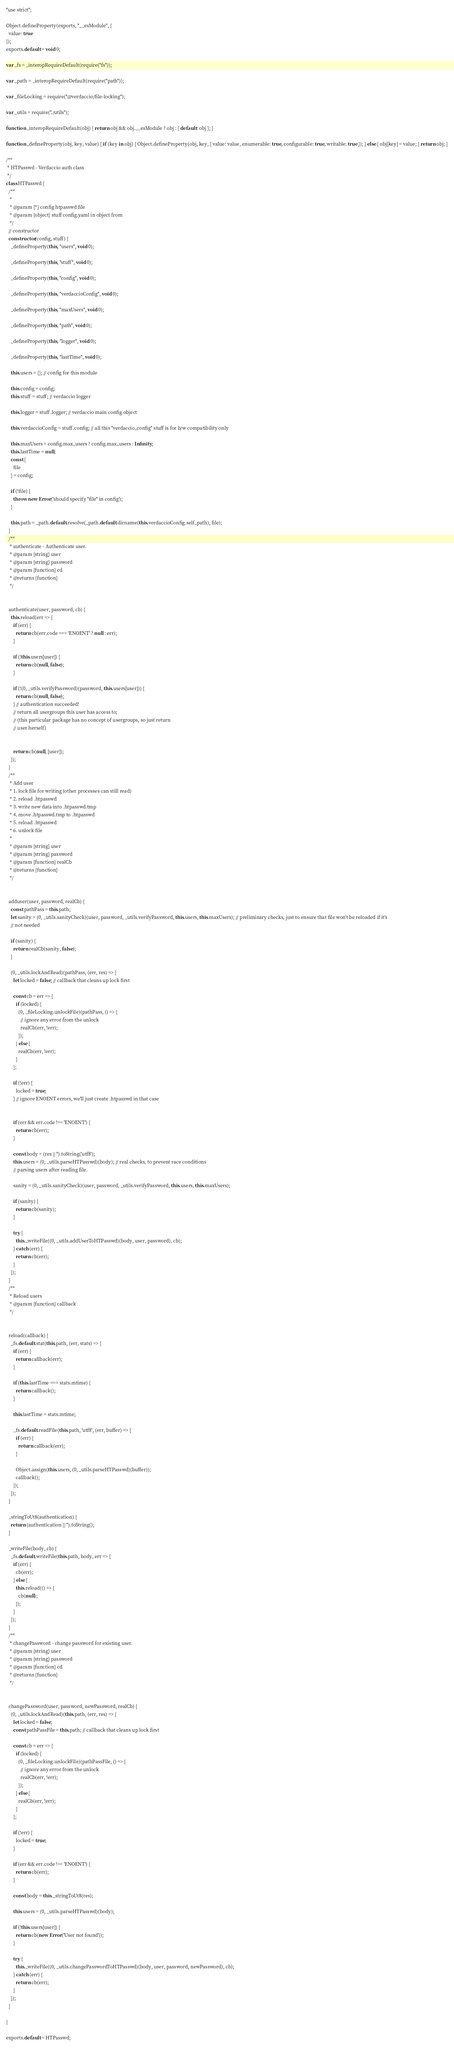<code> <loc_0><loc_0><loc_500><loc_500><_JavaScript_>"use strict";

Object.defineProperty(exports, "__esModule", {
  value: true
});
exports.default = void 0;

var _fs = _interopRequireDefault(require("fs"));

var _path = _interopRequireDefault(require("path"));

var _fileLocking = require("@verdaccio/file-locking");

var _utils = require("./utils");

function _interopRequireDefault(obj) { return obj && obj.__esModule ? obj : { default: obj }; }

function _defineProperty(obj, key, value) { if (key in obj) { Object.defineProperty(obj, key, { value: value, enumerable: true, configurable: true, writable: true }); } else { obj[key] = value; } return obj; }

/**
 * HTPasswd - Verdaccio auth class
 */
class HTPasswd {
  /**
   *
   * @param {*} config htpasswd file
   * @param {object} stuff config.yaml in object from
   */
  // constructor
  constructor(config, stuff) {
    _defineProperty(this, "users", void 0);

    _defineProperty(this, "stuff", void 0);

    _defineProperty(this, "config", void 0);

    _defineProperty(this, "verdaccioConfig", void 0);

    _defineProperty(this, "maxUsers", void 0);

    _defineProperty(this, "path", void 0);

    _defineProperty(this, "logger", void 0);

    _defineProperty(this, "lastTime", void 0);

    this.users = {}; // config for this module

    this.config = config;
    this.stuff = stuff; // verdaccio logger

    this.logger = stuff.logger; // verdaccio main config object

    this.verdaccioConfig = stuff.config; // all this "verdaccio_config" stuff is for b/w compatibility only

    this.maxUsers = config.max_users ? config.max_users : Infinity;
    this.lastTime = null;
    const {
      file
    } = config;

    if (!file) {
      throw new Error('should specify "file" in config');
    }

    this.path = _path.default.resolve(_path.default.dirname(this.verdaccioConfig.self_path), file);
  }
  /**
   * authenticate - Authenticate user.
   * @param {string} user
   * @param {string} password
   * @param {function} cd
   * @returns {function}
   */


  authenticate(user, password, cb) {
    this.reload(err => {
      if (err) {
        return cb(err.code === 'ENOENT' ? null : err);
      }

      if (!this.users[user]) {
        return cb(null, false);
      }

      if (!(0, _utils.verifyPassword)(password, this.users[user])) {
        return cb(null, false);
      } // authentication succeeded!
      // return all usergroups this user has access to;
      // (this particular package has no concept of usergroups, so just return
      // user herself)


      return cb(null, [user]);
    });
  }
  /**
   * Add user
   * 1. lock file for writing (other processes can still read)
   * 2. reload .htpasswd
   * 3. write new data into .htpasswd.tmp
   * 4. move .htpasswd.tmp to .htpasswd
   * 5. reload .htpasswd
   * 6. unlock file
   *
   * @param {string} user
   * @param {string} password
   * @param {function} realCb
   * @returns {function}
   */


  adduser(user, password, realCb) {
    const pathPass = this.path;
    let sanity = (0, _utils.sanityCheck)(user, password, _utils.verifyPassword, this.users, this.maxUsers); // preliminary checks, just to ensure that file won't be reloaded if it's
    // not needed

    if (sanity) {
      return realCb(sanity, false);
    }

    (0, _utils.lockAndRead)(pathPass, (err, res) => {
      let locked = false; // callback that cleans up lock first

      const cb = err => {
        if (locked) {
          (0, _fileLocking.unlockFile)(pathPass, () => {
            // ignore any error from the unlock
            realCb(err, !err);
          });
        } else {
          realCb(err, !err);
        }
      };

      if (!err) {
        locked = true;
      } // ignore ENOENT errors, we'll just create .htpasswd in that case


      if (err && err.code !== 'ENOENT') {
        return cb(err);
      }

      const body = (res || '').toString('utf8');
      this.users = (0, _utils.parseHTPasswd)(body); // real checks, to prevent race conditions
      // parsing users after reading file.

      sanity = (0, _utils.sanityCheck)(user, password, _utils.verifyPassword, this.users, this.maxUsers);

      if (sanity) {
        return cb(sanity);
      }

      try {
        this._writeFile((0, _utils.addUserToHTPasswd)(body, user, password), cb);
      } catch (err) {
        return cb(err);
      }
    });
  }
  /**
   * Reload users
   * @param {function} callback
   */


  reload(callback) {
    _fs.default.stat(this.path, (err, stats) => {
      if (err) {
        return callback(err);
      }

      if (this.lastTime === stats.mtime) {
        return callback();
      }

      this.lastTime = stats.mtime;

      _fs.default.readFile(this.path, 'utf8', (err, buffer) => {
        if (err) {
          return callback(err);
        }

        Object.assign(this.users, (0, _utils.parseHTPasswd)(buffer));
        callback();
      });
    });
  }

  _stringToUt8(authentication) {
    return (authentication || '').toString();
  }

  _writeFile(body, cb) {
    _fs.default.writeFile(this.path, body, err => {
      if (err) {
        cb(err);
      } else {
        this.reload(() => {
          cb(null);
        });
      }
    });
  }
  /**
   * changePassword - change password for existing user.
   * @param {string} user
   * @param {string} password
   * @param {function} cd
   * @returns {function}
   */


  changePassword(user, password, newPassword, realCb) {
    (0, _utils.lockAndRead)(this.path, (err, res) => {
      let locked = false;
      const pathPassFile = this.path; // callback that cleans up lock first

      const cb = err => {
        if (locked) {
          (0, _fileLocking.unlockFile)(pathPassFile, () => {
            // ignore any error from the unlock
            realCb(err, !err);
          });
        } else {
          realCb(err, !err);
        }
      };

      if (!err) {
        locked = true;
      }

      if (err && err.code !== 'ENOENT') {
        return cb(err);
      }

      const body = this._stringToUt8(res);

      this.users = (0, _utils.parseHTPasswd)(body);

      if (!this.users[user]) {
        return cb(new Error('User not found'));
      }

      try {
        this._writeFile((0, _utils.changePasswordToHTPasswd)(body, user, password, newPassword), cb);
      } catch (err) {
        return cb(err);
      }
    });
  }

}

exports.default = HTPasswd;</code> 